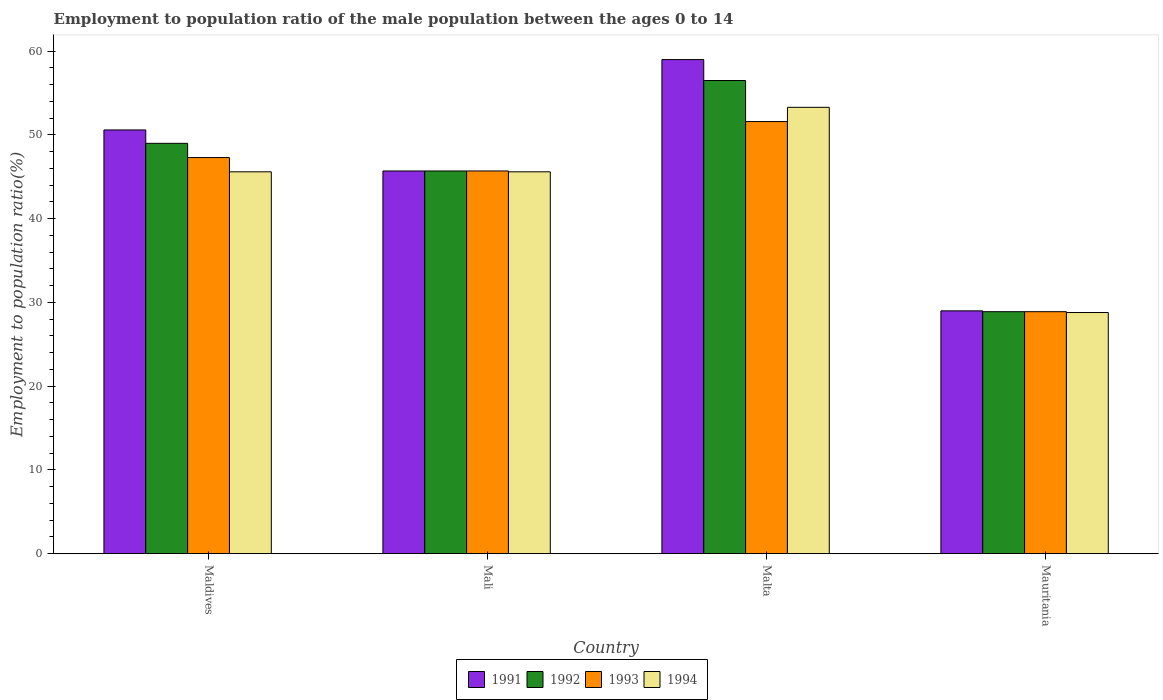How many bars are there on the 1st tick from the left?
Keep it short and to the point. 4. What is the label of the 4th group of bars from the left?
Make the answer very short. Mauritania. In how many cases, is the number of bars for a given country not equal to the number of legend labels?
Your response must be concise. 0. Across all countries, what is the maximum employment to population ratio in 1993?
Ensure brevity in your answer.  51.6. Across all countries, what is the minimum employment to population ratio in 1994?
Your answer should be compact. 28.8. In which country was the employment to population ratio in 1994 maximum?
Your response must be concise. Malta. In which country was the employment to population ratio in 1992 minimum?
Provide a short and direct response. Mauritania. What is the total employment to population ratio in 1993 in the graph?
Offer a terse response. 173.5. What is the difference between the employment to population ratio in 1992 in Maldives and that in Mauritania?
Your response must be concise. 20.1. What is the average employment to population ratio in 1991 per country?
Provide a short and direct response. 46.07. What is the difference between the employment to population ratio of/in 1992 and employment to population ratio of/in 1991 in Mauritania?
Make the answer very short. -0.1. In how many countries, is the employment to population ratio in 1991 greater than 54 %?
Offer a terse response. 1. What is the ratio of the employment to population ratio in 1991 in Mali to that in Mauritania?
Provide a succinct answer. 1.58. Is the employment to population ratio in 1991 in Maldives less than that in Malta?
Provide a short and direct response. Yes. What is the difference between the highest and the second highest employment to population ratio in 1993?
Provide a short and direct response. 5.9. What is the difference between the highest and the lowest employment to population ratio in 1993?
Provide a short and direct response. 22.7. Is the sum of the employment to population ratio in 1993 in Malta and Mauritania greater than the maximum employment to population ratio in 1992 across all countries?
Your answer should be very brief. Yes. Is it the case that in every country, the sum of the employment to population ratio in 1991 and employment to population ratio in 1993 is greater than the sum of employment to population ratio in 1994 and employment to population ratio in 1992?
Ensure brevity in your answer.  No. What does the 1st bar from the left in Mali represents?
Your response must be concise. 1991. What does the 4th bar from the right in Maldives represents?
Give a very brief answer. 1991. How many countries are there in the graph?
Give a very brief answer. 4. Are the values on the major ticks of Y-axis written in scientific E-notation?
Provide a short and direct response. No. Does the graph contain any zero values?
Offer a terse response. No. Does the graph contain grids?
Provide a short and direct response. No. Where does the legend appear in the graph?
Your answer should be very brief. Bottom center. How many legend labels are there?
Provide a succinct answer. 4. What is the title of the graph?
Keep it short and to the point. Employment to population ratio of the male population between the ages 0 to 14. What is the label or title of the X-axis?
Ensure brevity in your answer.  Country. What is the Employment to population ratio(%) of 1991 in Maldives?
Offer a very short reply. 50.6. What is the Employment to population ratio(%) in 1992 in Maldives?
Ensure brevity in your answer.  49. What is the Employment to population ratio(%) of 1993 in Maldives?
Offer a terse response. 47.3. What is the Employment to population ratio(%) of 1994 in Maldives?
Offer a very short reply. 45.6. What is the Employment to population ratio(%) of 1991 in Mali?
Ensure brevity in your answer.  45.7. What is the Employment to population ratio(%) in 1992 in Mali?
Provide a succinct answer. 45.7. What is the Employment to population ratio(%) of 1993 in Mali?
Offer a very short reply. 45.7. What is the Employment to population ratio(%) in 1994 in Mali?
Ensure brevity in your answer.  45.6. What is the Employment to population ratio(%) in 1992 in Malta?
Provide a short and direct response. 56.5. What is the Employment to population ratio(%) of 1993 in Malta?
Your response must be concise. 51.6. What is the Employment to population ratio(%) of 1994 in Malta?
Offer a terse response. 53.3. What is the Employment to population ratio(%) in 1992 in Mauritania?
Your answer should be very brief. 28.9. What is the Employment to population ratio(%) of 1993 in Mauritania?
Your response must be concise. 28.9. What is the Employment to population ratio(%) in 1994 in Mauritania?
Offer a very short reply. 28.8. Across all countries, what is the maximum Employment to population ratio(%) in 1991?
Offer a very short reply. 59. Across all countries, what is the maximum Employment to population ratio(%) of 1992?
Keep it short and to the point. 56.5. Across all countries, what is the maximum Employment to population ratio(%) of 1993?
Your response must be concise. 51.6. Across all countries, what is the maximum Employment to population ratio(%) in 1994?
Keep it short and to the point. 53.3. Across all countries, what is the minimum Employment to population ratio(%) in 1991?
Your response must be concise. 29. Across all countries, what is the minimum Employment to population ratio(%) in 1992?
Provide a short and direct response. 28.9. Across all countries, what is the minimum Employment to population ratio(%) of 1993?
Keep it short and to the point. 28.9. Across all countries, what is the minimum Employment to population ratio(%) of 1994?
Keep it short and to the point. 28.8. What is the total Employment to population ratio(%) of 1991 in the graph?
Your response must be concise. 184.3. What is the total Employment to population ratio(%) in 1992 in the graph?
Keep it short and to the point. 180.1. What is the total Employment to population ratio(%) of 1993 in the graph?
Offer a very short reply. 173.5. What is the total Employment to population ratio(%) in 1994 in the graph?
Your answer should be very brief. 173.3. What is the difference between the Employment to population ratio(%) in 1991 in Maldives and that in Mali?
Keep it short and to the point. 4.9. What is the difference between the Employment to population ratio(%) of 1994 in Maldives and that in Mali?
Your answer should be very brief. 0. What is the difference between the Employment to population ratio(%) of 1991 in Maldives and that in Malta?
Keep it short and to the point. -8.4. What is the difference between the Employment to population ratio(%) of 1993 in Maldives and that in Malta?
Give a very brief answer. -4.3. What is the difference between the Employment to population ratio(%) in 1991 in Maldives and that in Mauritania?
Keep it short and to the point. 21.6. What is the difference between the Employment to population ratio(%) of 1992 in Maldives and that in Mauritania?
Make the answer very short. 20.1. What is the difference between the Employment to population ratio(%) of 1993 in Maldives and that in Mauritania?
Ensure brevity in your answer.  18.4. What is the difference between the Employment to population ratio(%) of 1991 in Mali and that in Malta?
Your answer should be compact. -13.3. What is the difference between the Employment to population ratio(%) in 1992 in Mali and that in Malta?
Your answer should be very brief. -10.8. What is the difference between the Employment to population ratio(%) in 1993 in Mali and that in Malta?
Offer a very short reply. -5.9. What is the difference between the Employment to population ratio(%) in 1991 in Mali and that in Mauritania?
Your answer should be compact. 16.7. What is the difference between the Employment to population ratio(%) in 1994 in Mali and that in Mauritania?
Your answer should be very brief. 16.8. What is the difference between the Employment to population ratio(%) of 1991 in Malta and that in Mauritania?
Offer a terse response. 30. What is the difference between the Employment to population ratio(%) in 1992 in Malta and that in Mauritania?
Provide a succinct answer. 27.6. What is the difference between the Employment to population ratio(%) in 1993 in Malta and that in Mauritania?
Offer a terse response. 22.7. What is the difference between the Employment to population ratio(%) of 1991 in Maldives and the Employment to population ratio(%) of 1994 in Mali?
Provide a succinct answer. 5. What is the difference between the Employment to population ratio(%) of 1992 in Maldives and the Employment to population ratio(%) of 1994 in Mali?
Provide a succinct answer. 3.4. What is the difference between the Employment to population ratio(%) of 1993 in Maldives and the Employment to population ratio(%) of 1994 in Mali?
Make the answer very short. 1.7. What is the difference between the Employment to population ratio(%) in 1991 in Maldives and the Employment to population ratio(%) in 1992 in Malta?
Provide a short and direct response. -5.9. What is the difference between the Employment to population ratio(%) in 1991 in Maldives and the Employment to population ratio(%) in 1993 in Malta?
Provide a short and direct response. -1. What is the difference between the Employment to population ratio(%) of 1991 in Maldives and the Employment to population ratio(%) of 1994 in Malta?
Your answer should be very brief. -2.7. What is the difference between the Employment to population ratio(%) of 1993 in Maldives and the Employment to population ratio(%) of 1994 in Malta?
Provide a succinct answer. -6. What is the difference between the Employment to population ratio(%) of 1991 in Maldives and the Employment to population ratio(%) of 1992 in Mauritania?
Ensure brevity in your answer.  21.7. What is the difference between the Employment to population ratio(%) in 1991 in Maldives and the Employment to population ratio(%) in 1993 in Mauritania?
Provide a short and direct response. 21.7. What is the difference between the Employment to population ratio(%) in 1991 in Maldives and the Employment to population ratio(%) in 1994 in Mauritania?
Provide a succinct answer. 21.8. What is the difference between the Employment to population ratio(%) in 1992 in Maldives and the Employment to population ratio(%) in 1993 in Mauritania?
Provide a succinct answer. 20.1. What is the difference between the Employment to population ratio(%) in 1992 in Maldives and the Employment to population ratio(%) in 1994 in Mauritania?
Give a very brief answer. 20.2. What is the difference between the Employment to population ratio(%) in 1991 in Mali and the Employment to population ratio(%) in 1992 in Malta?
Your response must be concise. -10.8. What is the difference between the Employment to population ratio(%) in 1992 in Mali and the Employment to population ratio(%) in 1993 in Malta?
Your answer should be very brief. -5.9. What is the difference between the Employment to population ratio(%) of 1992 in Mali and the Employment to population ratio(%) of 1994 in Malta?
Give a very brief answer. -7.6. What is the difference between the Employment to population ratio(%) in 1993 in Mali and the Employment to population ratio(%) in 1994 in Malta?
Your answer should be compact. -7.6. What is the difference between the Employment to population ratio(%) in 1991 in Mali and the Employment to population ratio(%) in 1992 in Mauritania?
Your answer should be compact. 16.8. What is the difference between the Employment to population ratio(%) of 1991 in Mali and the Employment to population ratio(%) of 1994 in Mauritania?
Offer a very short reply. 16.9. What is the difference between the Employment to population ratio(%) in 1992 in Mali and the Employment to population ratio(%) in 1993 in Mauritania?
Make the answer very short. 16.8. What is the difference between the Employment to population ratio(%) in 1992 in Mali and the Employment to population ratio(%) in 1994 in Mauritania?
Your answer should be compact. 16.9. What is the difference between the Employment to population ratio(%) of 1991 in Malta and the Employment to population ratio(%) of 1992 in Mauritania?
Keep it short and to the point. 30.1. What is the difference between the Employment to population ratio(%) of 1991 in Malta and the Employment to population ratio(%) of 1993 in Mauritania?
Keep it short and to the point. 30.1. What is the difference between the Employment to population ratio(%) of 1991 in Malta and the Employment to population ratio(%) of 1994 in Mauritania?
Give a very brief answer. 30.2. What is the difference between the Employment to population ratio(%) in 1992 in Malta and the Employment to population ratio(%) in 1993 in Mauritania?
Your answer should be very brief. 27.6. What is the difference between the Employment to population ratio(%) of 1992 in Malta and the Employment to population ratio(%) of 1994 in Mauritania?
Your response must be concise. 27.7. What is the difference between the Employment to population ratio(%) in 1993 in Malta and the Employment to population ratio(%) in 1994 in Mauritania?
Your answer should be very brief. 22.8. What is the average Employment to population ratio(%) in 1991 per country?
Provide a succinct answer. 46.08. What is the average Employment to population ratio(%) of 1992 per country?
Offer a terse response. 45.02. What is the average Employment to population ratio(%) in 1993 per country?
Your answer should be very brief. 43.38. What is the average Employment to population ratio(%) of 1994 per country?
Offer a terse response. 43.33. What is the difference between the Employment to population ratio(%) of 1991 and Employment to population ratio(%) of 1992 in Maldives?
Your answer should be very brief. 1.6. What is the difference between the Employment to population ratio(%) in 1991 and Employment to population ratio(%) in 1993 in Maldives?
Offer a terse response. 3.3. What is the difference between the Employment to population ratio(%) of 1991 and Employment to population ratio(%) of 1994 in Maldives?
Your answer should be very brief. 5. What is the difference between the Employment to population ratio(%) of 1992 and Employment to population ratio(%) of 1994 in Maldives?
Provide a succinct answer. 3.4. What is the difference between the Employment to population ratio(%) of 1993 and Employment to population ratio(%) of 1994 in Maldives?
Provide a succinct answer. 1.7. What is the difference between the Employment to population ratio(%) in 1992 and Employment to population ratio(%) in 1994 in Mali?
Offer a very short reply. 0.1. What is the difference between the Employment to population ratio(%) of 1991 and Employment to population ratio(%) of 1992 in Malta?
Make the answer very short. 2.5. What is the difference between the Employment to population ratio(%) of 1992 and Employment to population ratio(%) of 1993 in Malta?
Your answer should be compact. 4.9. What is the difference between the Employment to population ratio(%) of 1993 and Employment to population ratio(%) of 1994 in Malta?
Ensure brevity in your answer.  -1.7. What is the difference between the Employment to population ratio(%) in 1991 and Employment to population ratio(%) in 1992 in Mauritania?
Keep it short and to the point. 0.1. What is the difference between the Employment to population ratio(%) of 1992 and Employment to population ratio(%) of 1993 in Mauritania?
Your answer should be compact. 0. What is the ratio of the Employment to population ratio(%) of 1991 in Maldives to that in Mali?
Make the answer very short. 1.11. What is the ratio of the Employment to population ratio(%) of 1992 in Maldives to that in Mali?
Your answer should be compact. 1.07. What is the ratio of the Employment to population ratio(%) in 1993 in Maldives to that in Mali?
Provide a succinct answer. 1.03. What is the ratio of the Employment to population ratio(%) of 1994 in Maldives to that in Mali?
Your answer should be very brief. 1. What is the ratio of the Employment to population ratio(%) of 1991 in Maldives to that in Malta?
Provide a short and direct response. 0.86. What is the ratio of the Employment to population ratio(%) of 1992 in Maldives to that in Malta?
Give a very brief answer. 0.87. What is the ratio of the Employment to population ratio(%) of 1994 in Maldives to that in Malta?
Provide a short and direct response. 0.86. What is the ratio of the Employment to population ratio(%) of 1991 in Maldives to that in Mauritania?
Offer a terse response. 1.74. What is the ratio of the Employment to population ratio(%) in 1992 in Maldives to that in Mauritania?
Provide a succinct answer. 1.7. What is the ratio of the Employment to population ratio(%) of 1993 in Maldives to that in Mauritania?
Offer a very short reply. 1.64. What is the ratio of the Employment to population ratio(%) of 1994 in Maldives to that in Mauritania?
Offer a very short reply. 1.58. What is the ratio of the Employment to population ratio(%) in 1991 in Mali to that in Malta?
Make the answer very short. 0.77. What is the ratio of the Employment to population ratio(%) of 1992 in Mali to that in Malta?
Make the answer very short. 0.81. What is the ratio of the Employment to population ratio(%) in 1993 in Mali to that in Malta?
Keep it short and to the point. 0.89. What is the ratio of the Employment to population ratio(%) of 1994 in Mali to that in Malta?
Offer a very short reply. 0.86. What is the ratio of the Employment to population ratio(%) of 1991 in Mali to that in Mauritania?
Make the answer very short. 1.58. What is the ratio of the Employment to population ratio(%) of 1992 in Mali to that in Mauritania?
Keep it short and to the point. 1.58. What is the ratio of the Employment to population ratio(%) in 1993 in Mali to that in Mauritania?
Give a very brief answer. 1.58. What is the ratio of the Employment to population ratio(%) of 1994 in Mali to that in Mauritania?
Ensure brevity in your answer.  1.58. What is the ratio of the Employment to population ratio(%) of 1991 in Malta to that in Mauritania?
Your response must be concise. 2.03. What is the ratio of the Employment to population ratio(%) in 1992 in Malta to that in Mauritania?
Provide a short and direct response. 1.96. What is the ratio of the Employment to population ratio(%) in 1993 in Malta to that in Mauritania?
Provide a short and direct response. 1.79. What is the ratio of the Employment to population ratio(%) in 1994 in Malta to that in Mauritania?
Ensure brevity in your answer.  1.85. What is the difference between the highest and the second highest Employment to population ratio(%) of 1991?
Your answer should be very brief. 8.4. What is the difference between the highest and the second highest Employment to population ratio(%) of 1992?
Your response must be concise. 7.5. What is the difference between the highest and the second highest Employment to population ratio(%) of 1993?
Offer a terse response. 4.3. What is the difference between the highest and the lowest Employment to population ratio(%) in 1992?
Your response must be concise. 27.6. What is the difference between the highest and the lowest Employment to population ratio(%) of 1993?
Your answer should be compact. 22.7. 